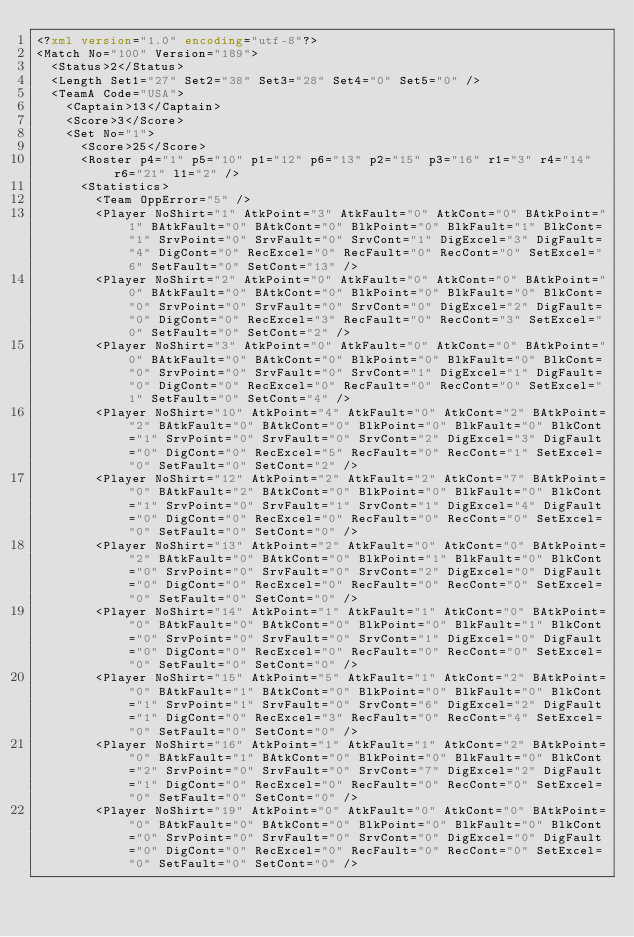Convert code to text. <code><loc_0><loc_0><loc_500><loc_500><_XML_><?xml version="1.0" encoding="utf-8"?>
<Match No="100" Version="189">
  <Status>2</Status>
  <Length Set1="27" Set2="38" Set3="28" Set4="0" Set5="0" />
  <TeamA Code="USA">
    <Captain>13</Captain>
    <Score>3</Score>
    <Set No="1">
      <Score>25</Score>
      <Roster p4="1" p5="10" p1="12" p6="13" p2="15" p3="16" r1="3" r4="14" r6="21" l1="2" />
      <Statistics>
        <Team OppError="5" />
        <Player NoShirt="1" AtkPoint="3" AtkFault="0" AtkCont="0" BAtkPoint="1" BAtkFault="0" BAtkCont="0" BlkPoint="0" BlkFault="1" BlkCont="1" SrvPoint="0" SrvFault="0" SrvCont="1" DigExcel="3" DigFault="4" DigCont="0" RecExcel="0" RecFault="0" RecCont="0" SetExcel="6" SetFault="0" SetCont="13" />
        <Player NoShirt="2" AtkPoint="0" AtkFault="0" AtkCont="0" BAtkPoint="0" BAtkFault="0" BAtkCont="0" BlkPoint="0" BlkFault="0" BlkCont="0" SrvPoint="0" SrvFault="0" SrvCont="0" DigExcel="2" DigFault="0" DigCont="0" RecExcel="3" RecFault="0" RecCont="3" SetExcel="0" SetFault="0" SetCont="2" />
        <Player NoShirt="3" AtkPoint="0" AtkFault="0" AtkCont="0" BAtkPoint="0" BAtkFault="0" BAtkCont="0" BlkPoint="0" BlkFault="0" BlkCont="0" SrvPoint="0" SrvFault="0" SrvCont="1" DigExcel="1" DigFault="0" DigCont="0" RecExcel="0" RecFault="0" RecCont="0" SetExcel="1" SetFault="0" SetCont="4" />
        <Player NoShirt="10" AtkPoint="4" AtkFault="0" AtkCont="2" BAtkPoint="2" BAtkFault="0" BAtkCont="0" BlkPoint="0" BlkFault="0" BlkCont="1" SrvPoint="0" SrvFault="0" SrvCont="2" DigExcel="3" DigFault="0" DigCont="0" RecExcel="5" RecFault="0" RecCont="1" SetExcel="0" SetFault="0" SetCont="2" />
        <Player NoShirt="12" AtkPoint="2" AtkFault="2" AtkCont="7" BAtkPoint="0" BAtkFault="2" BAtkCont="0" BlkPoint="0" BlkFault="0" BlkCont="1" SrvPoint="0" SrvFault="1" SrvCont="1" DigExcel="4" DigFault="0" DigCont="0" RecExcel="0" RecFault="0" RecCont="0" SetExcel="0" SetFault="0" SetCont="0" />
        <Player NoShirt="13" AtkPoint="2" AtkFault="0" AtkCont="0" BAtkPoint="2" BAtkFault="0" BAtkCont="0" BlkPoint="1" BlkFault="0" BlkCont="0" SrvPoint="0" SrvFault="0" SrvCont="2" DigExcel="0" DigFault="0" DigCont="0" RecExcel="0" RecFault="0" RecCont="0" SetExcel="0" SetFault="0" SetCont="0" />
        <Player NoShirt="14" AtkPoint="1" AtkFault="1" AtkCont="0" BAtkPoint="0" BAtkFault="0" BAtkCont="0" BlkPoint="0" BlkFault="1" BlkCont="0" SrvPoint="0" SrvFault="0" SrvCont="1" DigExcel="0" DigFault="0" DigCont="0" RecExcel="0" RecFault="0" RecCont="0" SetExcel="0" SetFault="0" SetCont="0" />
        <Player NoShirt="15" AtkPoint="5" AtkFault="1" AtkCont="2" BAtkPoint="0" BAtkFault="1" BAtkCont="0" BlkPoint="0" BlkFault="0" BlkCont="1" SrvPoint="1" SrvFault="0" SrvCont="6" DigExcel="2" DigFault="1" DigCont="0" RecExcel="3" RecFault="0" RecCont="4" SetExcel="0" SetFault="0" SetCont="0" />
        <Player NoShirt="16" AtkPoint="1" AtkFault="1" AtkCont="2" BAtkPoint="0" BAtkFault="1" BAtkCont="0" BlkPoint="0" BlkFault="0" BlkCont="2" SrvPoint="0" SrvFault="0" SrvCont="7" DigExcel="2" DigFault="1" DigCont="0" RecExcel="0" RecFault="0" RecCont="0" SetExcel="0" SetFault="0" SetCont="0" />
        <Player NoShirt="19" AtkPoint="0" AtkFault="0" AtkCont="0" BAtkPoint="0" BAtkFault="0" BAtkCont="0" BlkPoint="0" BlkFault="0" BlkCont="0" SrvPoint="0" SrvFault="0" SrvCont="0" DigExcel="0" DigFault="0" DigCont="0" RecExcel="0" RecFault="0" RecCont="0" SetExcel="0" SetFault="0" SetCont="0" /></code> 